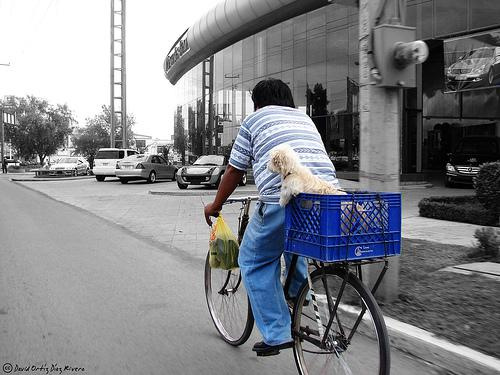Question: why is he riding the bike?
Choices:
A. Transportation.
B. For exercise.
C. For fun.
D. To race.
Answer with the letter. Answer: A Question: who is riding the bike?
Choices:
A. Two men.
B. Person.
C. Two women.
D. Two children.
Answer with the letter. Answer: B Question: what color is the tires?
Choices:
A. Grey.
B. White.
C. Blue.
D. Black.
Answer with the letter. Answer: D Question: how many dogs are there?
Choices:
A. 7.
B. 8.
C. 9.
D. 1.
Answer with the letter. Answer: D 